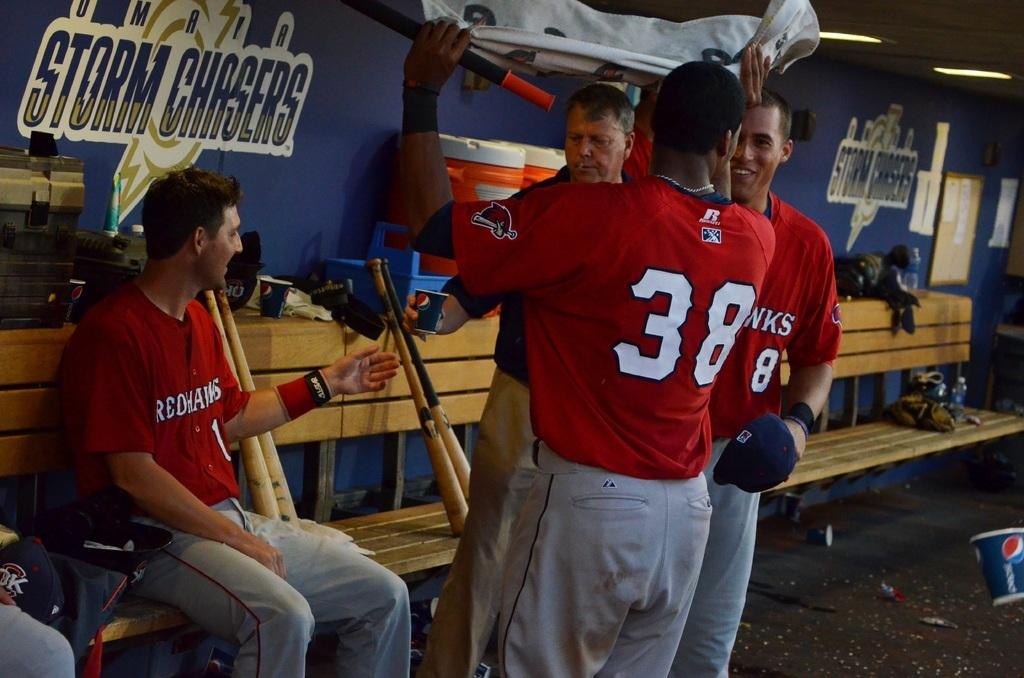<image>
Offer a succinct explanation of the picture presented. Redhawks is the team name shown on these player's uniforms. 